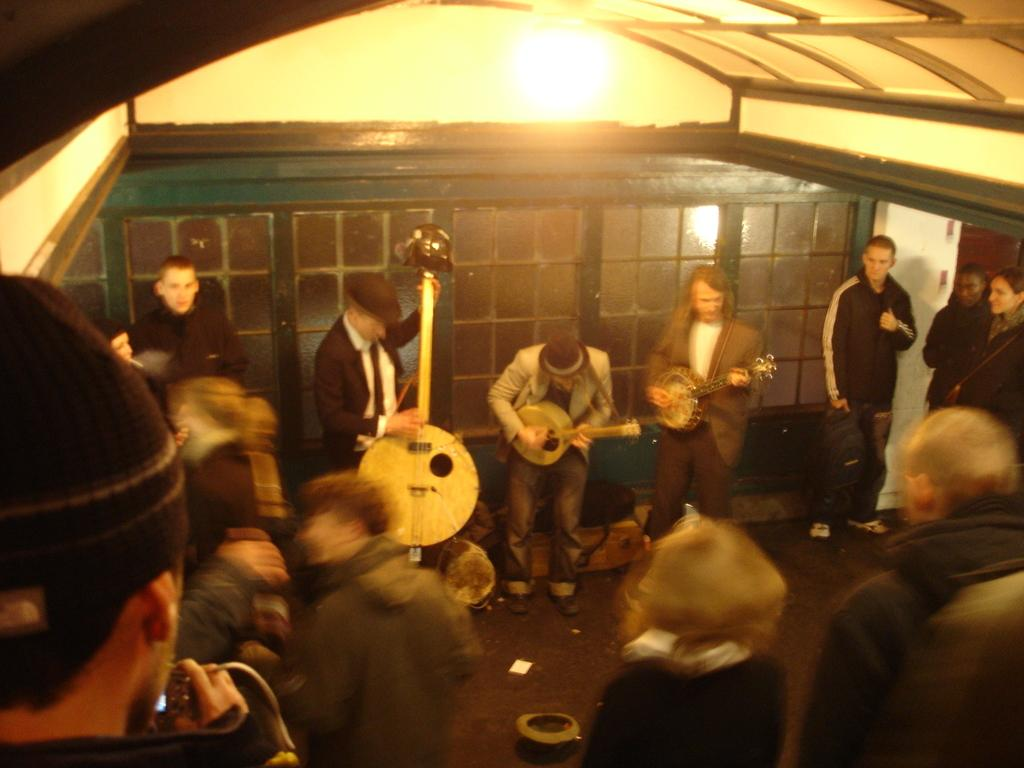What are the people in the image doing? The people in the image are standing and holding musical instruments. What can be seen in the background of the image? There is a wall in the background of the image. What is visible at the top of the image? There is a roof visible at the top of the image. What might be used to provide illumination in the image? There are lights present in the image. What type of wool is being used by the people in the image? There is no wool present in the image; the people are holding musical instruments. What book is the person reading in the image? There is no person reading a book in the image; the people are holding musical instruments. 